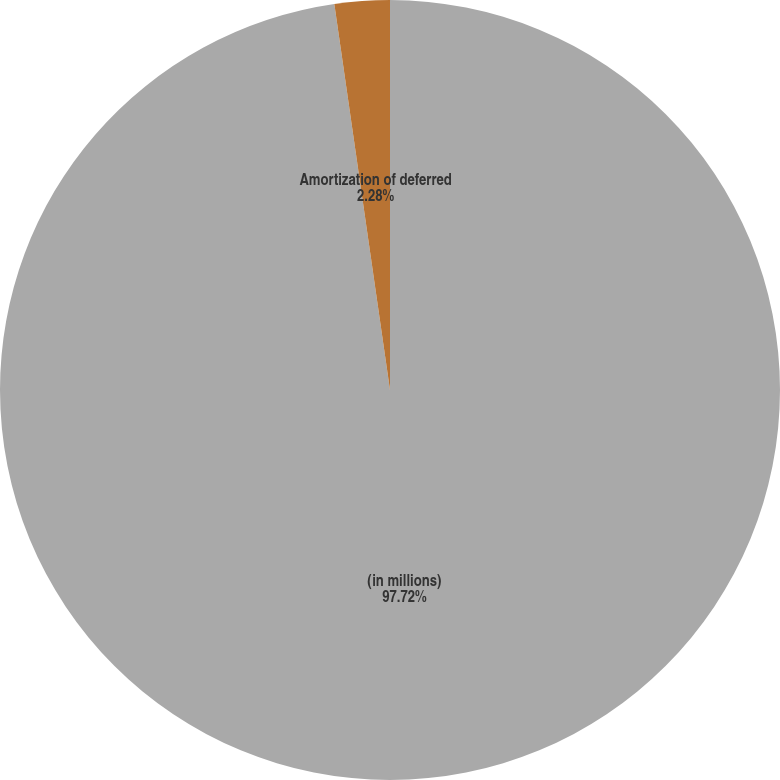Convert chart to OTSL. <chart><loc_0><loc_0><loc_500><loc_500><pie_chart><fcel>(in millions)<fcel>Amortization of deferred<nl><fcel>97.72%<fcel>2.28%<nl></chart> 